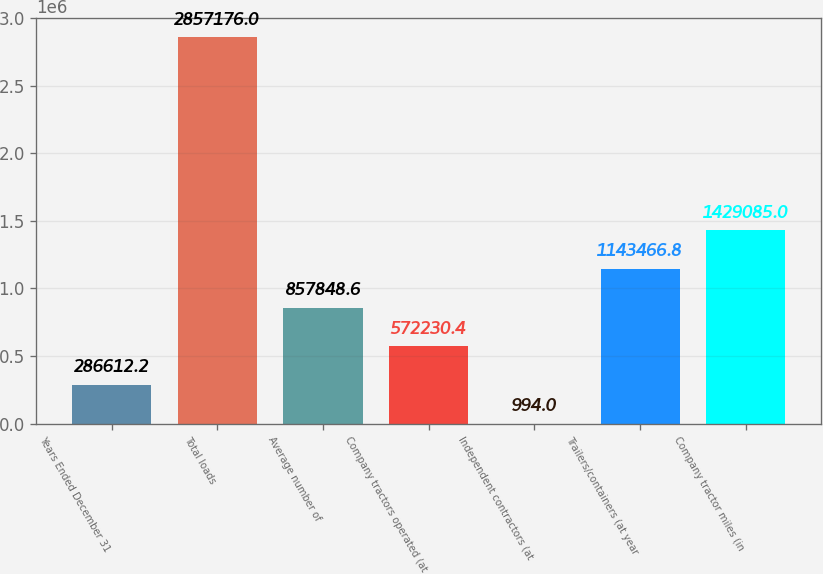Convert chart. <chart><loc_0><loc_0><loc_500><loc_500><bar_chart><fcel>Years Ended December 31<fcel>Total loads<fcel>Average number of<fcel>Company tractors operated (at<fcel>Independent contractors (at<fcel>Trailers/containers (at year<fcel>Company tractor miles (in<nl><fcel>286612<fcel>2.85718e+06<fcel>857849<fcel>572230<fcel>994<fcel>1.14347e+06<fcel>1.42908e+06<nl></chart> 